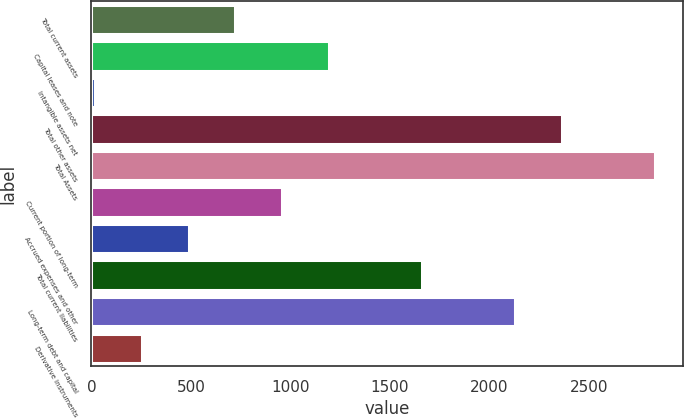Convert chart to OTSL. <chart><loc_0><loc_0><loc_500><loc_500><bar_chart><fcel>Total current assets<fcel>Capital leases and note<fcel>Intangible assets net<fcel>Total other assets<fcel>Total Assets<fcel>Current portion of long-term<fcel>Accrued expenses and other<fcel>Total current liabilities<fcel>Long-term debt and capital<fcel>Derivative instruments<nl><fcel>723.5<fcel>1192.5<fcel>20<fcel>2365<fcel>2834<fcel>958<fcel>489<fcel>1661.5<fcel>2130.5<fcel>254.5<nl></chart> 